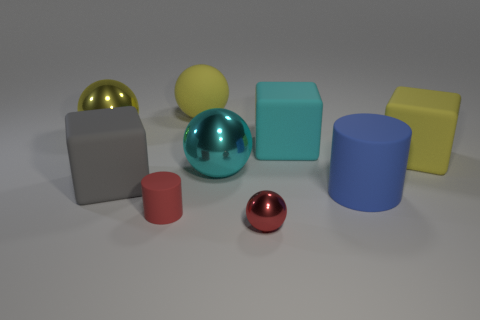Which geometric shapes can you identify in this image? In the image, I can identify several geometric shapes: there are spheres, a cube, a cylinder, and what looks to be rectangular prisms or cuboids.  How many objects have a distinct reflective surface? From what can be seen, there are two objects with a distinctly reflective surface, one being the sphere with a chrome-like appearance, and the other one is the golden sphere. 